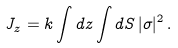Convert formula to latex. <formula><loc_0><loc_0><loc_500><loc_500>J _ { z } = k \int d z \int d S \, | \sigma | ^ { 2 } \, .</formula> 